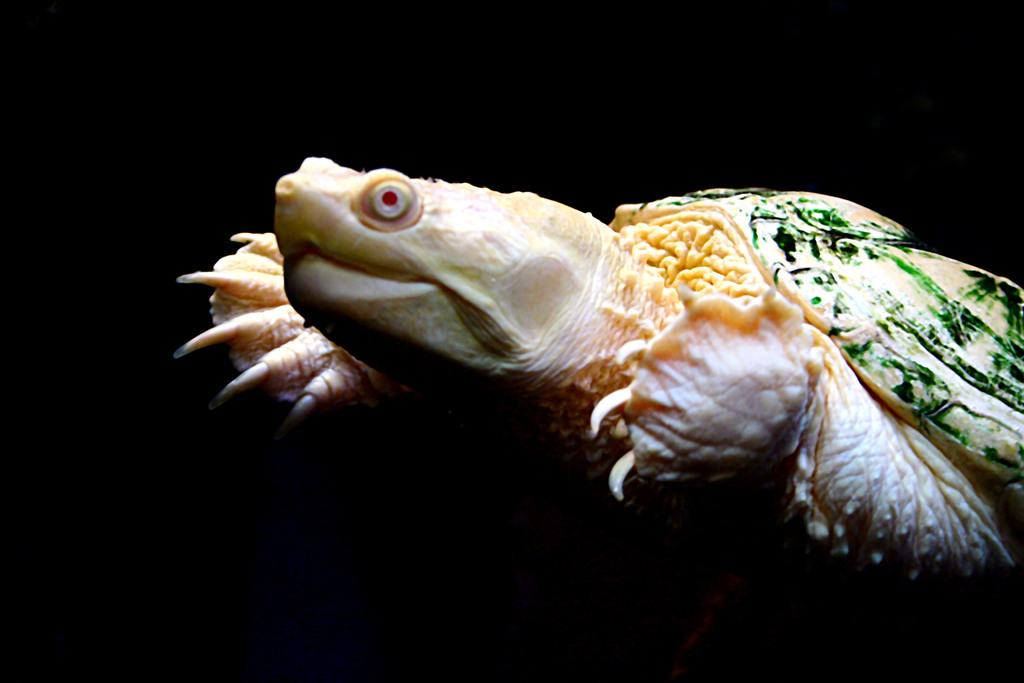What animal is the main subject of the picture? There is a tortoise in the picture. What colors can be seen on the tortoise? The tortoise has cream and green colors. How would you describe the background of the image? The background of the image is dark. Can you see any copper objects near the tortoise in the image? There is no copper object present in the image. Are there any giants visible in the image? There are no giants present in the image; it features a tortoise. 